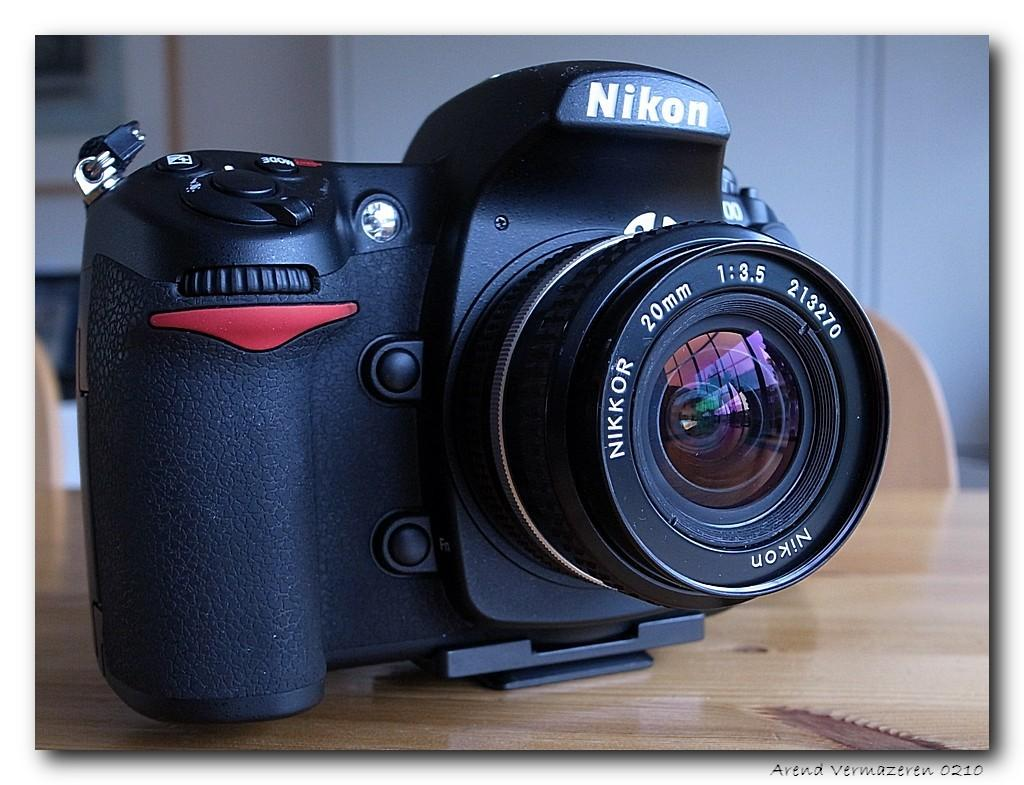What object is the main subject in the image? There is a camera in the image. Can you describe any specific features of the camera? The camera has a nick. Where is the camera located in the image? The camera is on a table. Can you tell me how many bushes are growing in the lunchroom in the image? There are no bushes or lunchroom present in the image; it features a camera on a table. What type of stream can be seen flowing through the camera in the image? There is no stream present in the image, as it features a camera on a table. 